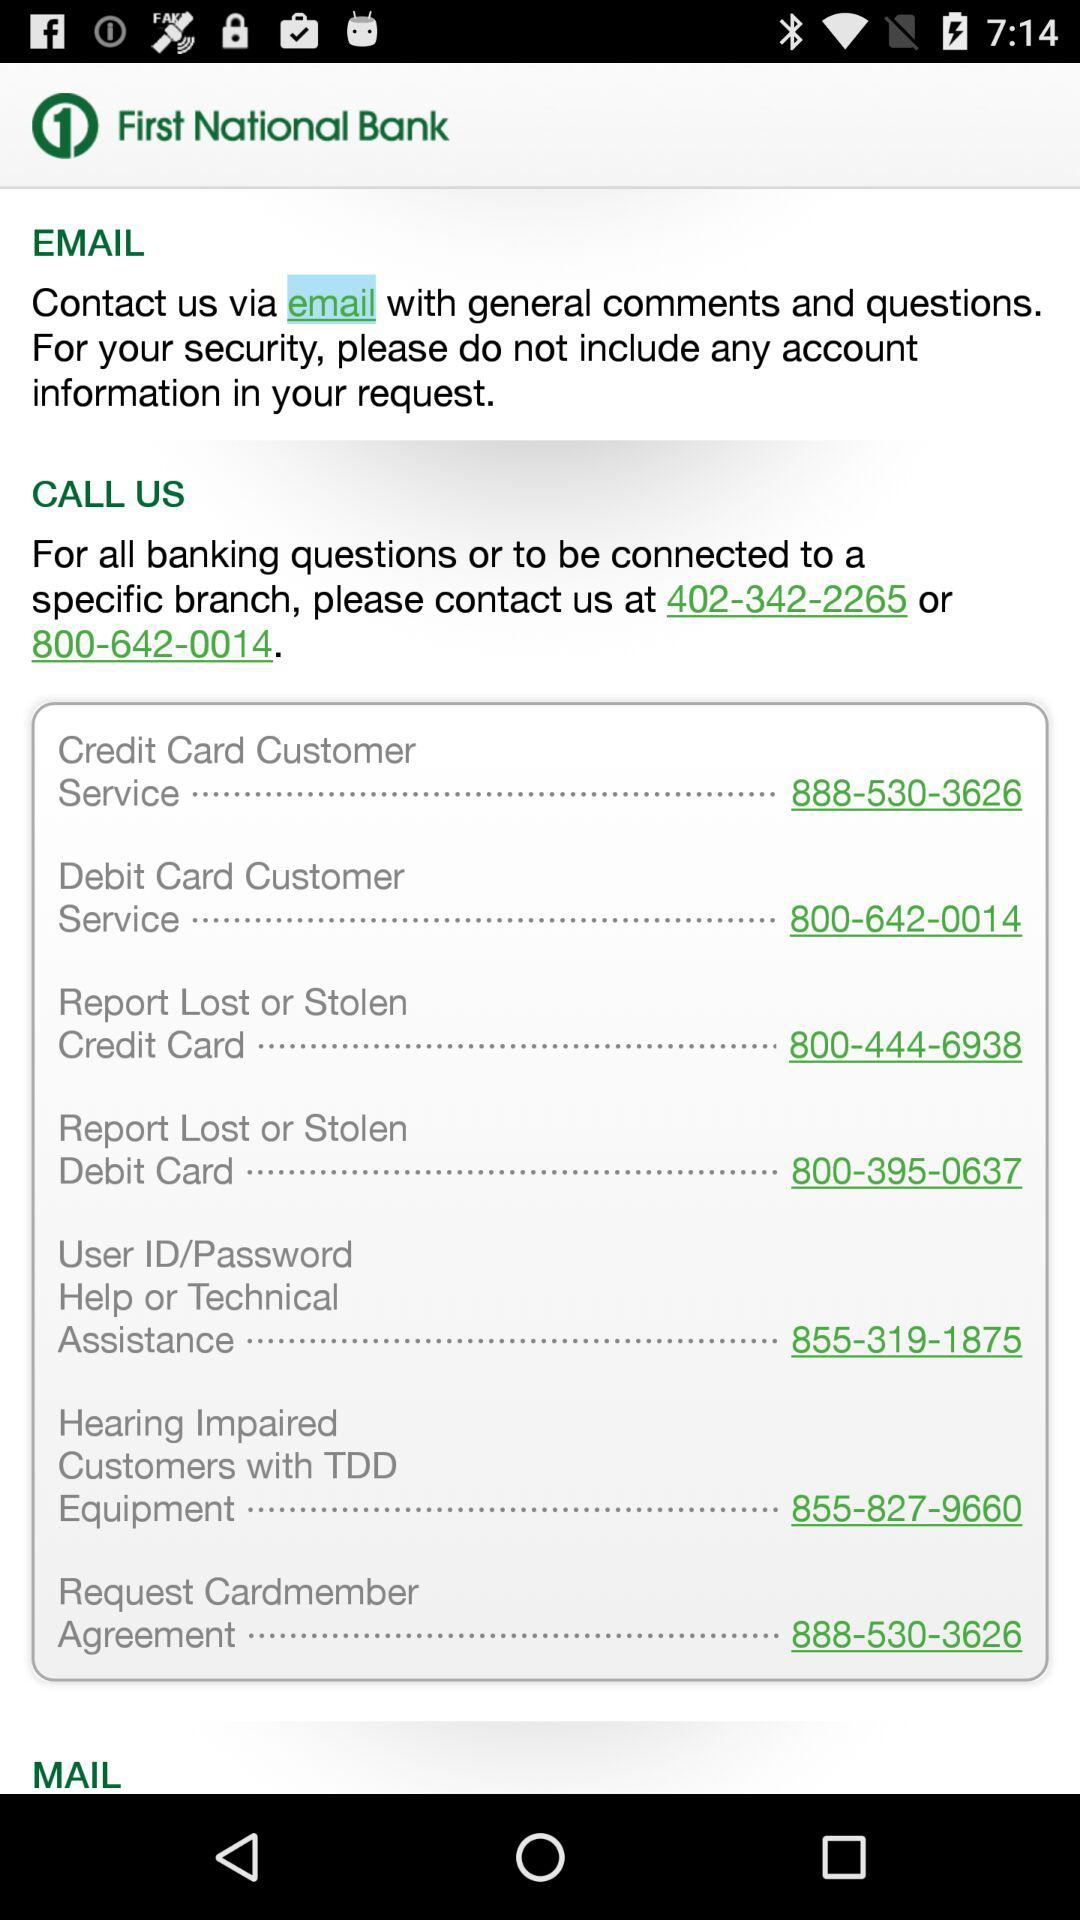What is the contact number for debit card customer service? The contact number for debit card customer service is 800-642-0014. 